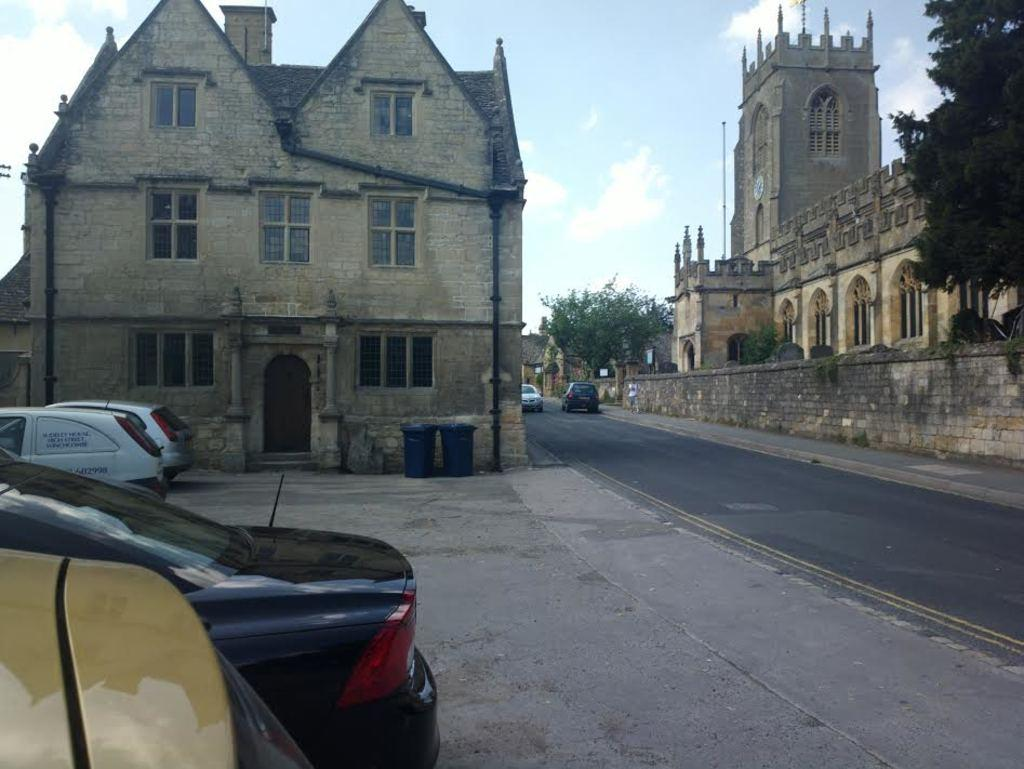What type of structures can be seen in the image? There are buildings in the image. What type of vegetation is on the right side of the image? There is a green tree on the right side of the image. What type of vehicles are visible in the image? There are cars visible in the image. What is visible at the top of the image? The sky is visible at the top of the image. What type of cup can be seen in the image? There is no cup present in the image. What discovery was made by the people in the image? There are no people or any indication of a discovery in the image. 